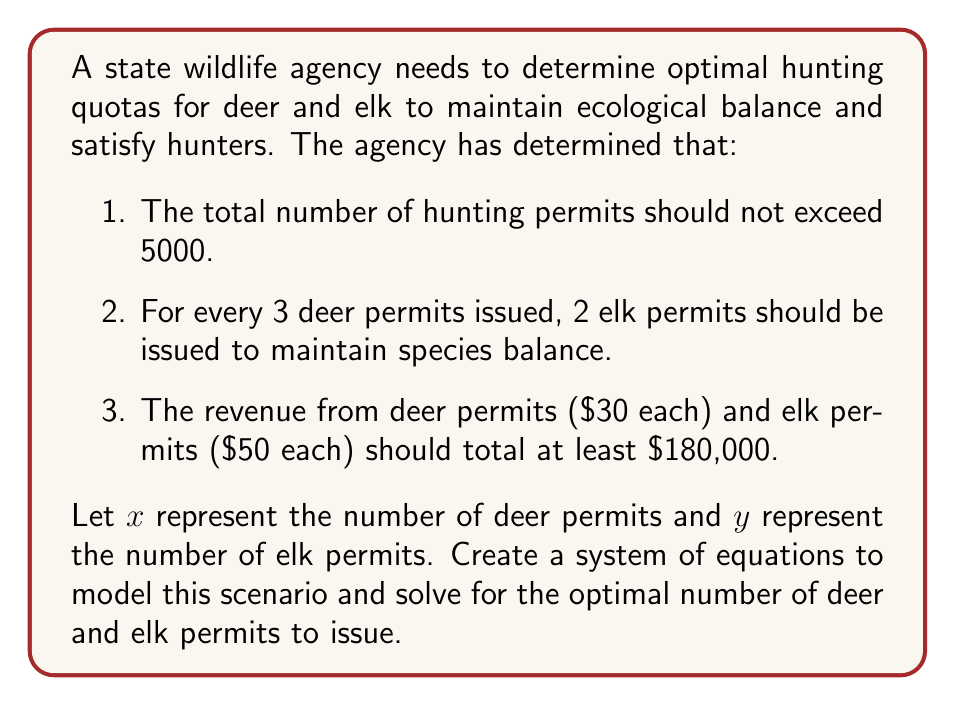Teach me how to tackle this problem. Let's approach this step-by-step:

1. Translate the given conditions into equations:
   a. Total permits: $x + y = 5000$
   b. Ratio of deer to elk permits: $\frac{x}{3} = \frac{y}{2}$ or $2x = 3y$
   c. Revenue: $30x + 50y \geq 180000$

2. We now have a system of equations:
   $$\begin{cases}
   x + y = 5000 \\
   2x = 3y \\
   30x + 50y \geq 180000
   \end{cases}$$

3. From the second equation, express $x$ in terms of $y$:
   $x = \frac{3y}{2}$

4. Substitute this into the first equation:
   $\frac{3y}{2} + y = 5000$
   $\frac{5y}{2} = 5000$
   $y = 2000$

5. Calculate $x$:
   $x = \frac{3(2000)}{2} = 3000$

6. Verify the revenue condition:
   $30(3000) + 50(2000) = 90000 + 100000 = 190000 \geq 180000$

Therefore, the optimal solution is to issue 3000 deer permits and 2000 elk permits.
Answer: 3000 deer permits, 2000 elk permits 